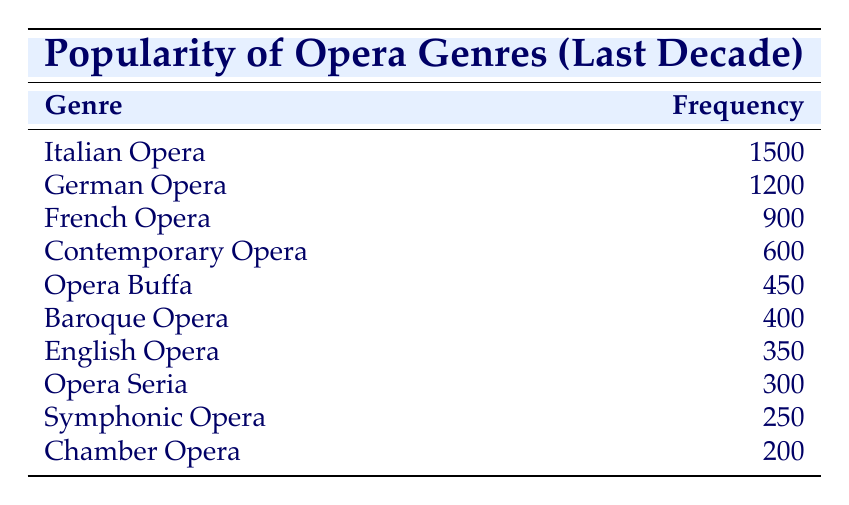What's the frequency of Italian Opera? The table directly lists the frequency of each genre. Italian Opera has a frequency of 1500.
Answer: 1500 Which opera genre has the lowest frequency? Looking through the frequencies listed, Chamber Opera, with a frequency of 200, has the lowest value compared to the others.
Answer: Chamber Opera What is the total frequency of Italian and German Opera combined? To find the total frequency, add the values for Italian Opera (1500) and German Opera (1200): 1500 + 1200 = 2700.
Answer: 2700 Is Contemporary Opera more popular than Opera Buffa? Comparing their frequencies, Contemporary Opera (600) is greater than Opera Buffa (450), confirming that Contemporary Opera is indeed more popular.
Answer: Yes What is the average frequency of the genres listed in the table? First, sum all the frequencies: 1500 + 1200 + 900 + 600 + 450 + 400 + 350 + 300 + 250 + 200 = 4850. There are 10 genres, so the average is 4850 / 10 = 485.
Answer: 485 What percentage of the total frequency does German Opera represent? First, calculate the total frequency, which is 4850. Then find the frequency of German Opera (1200) and divide by the total: (1200 / 4850) * 100 = approximately 24.8%.
Answer: 24.8% Are there more than three genres with a frequency of 500 or above? Count the genres with frequencies of 500 or more: Italian Opera (1500), German Opera (1200), French Opera (900), and Contemporary Opera (600). This gives us four genres, thus confirming the statement is true.
Answer: Yes What is the difference in frequency between the most and least popular genres? The most popular genre is Italian Opera with a frequency of 1500, and the least popular is Chamber Opera with 200. The difference is 1500 - 200 = 1300.
Answer: 1300 